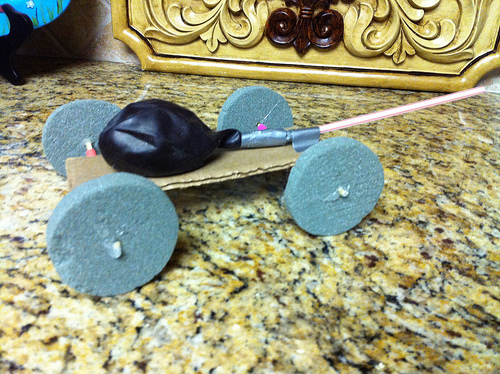<image>
Can you confirm if the baloon is next to the wheel? Yes. The baloon is positioned adjacent to the wheel, located nearby in the same general area. 